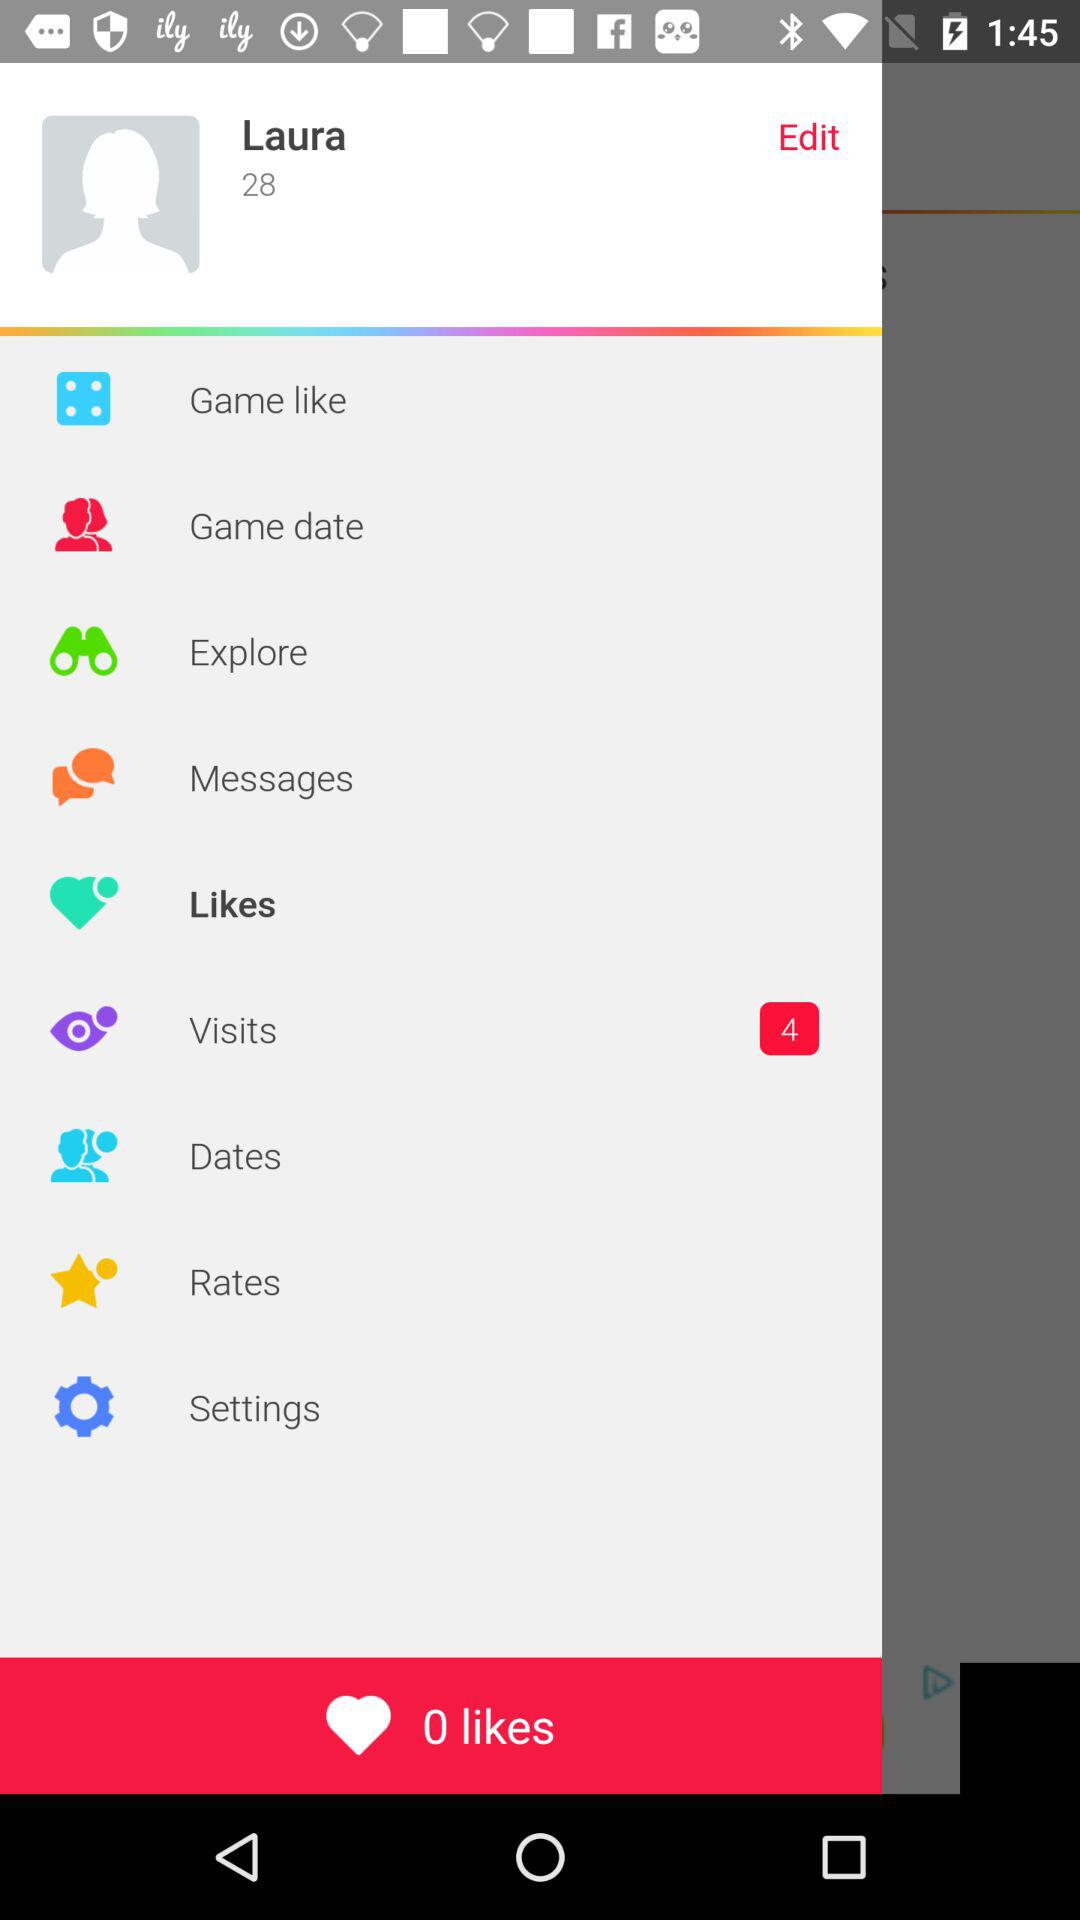What is the number of likes? The number of likes is 0. 